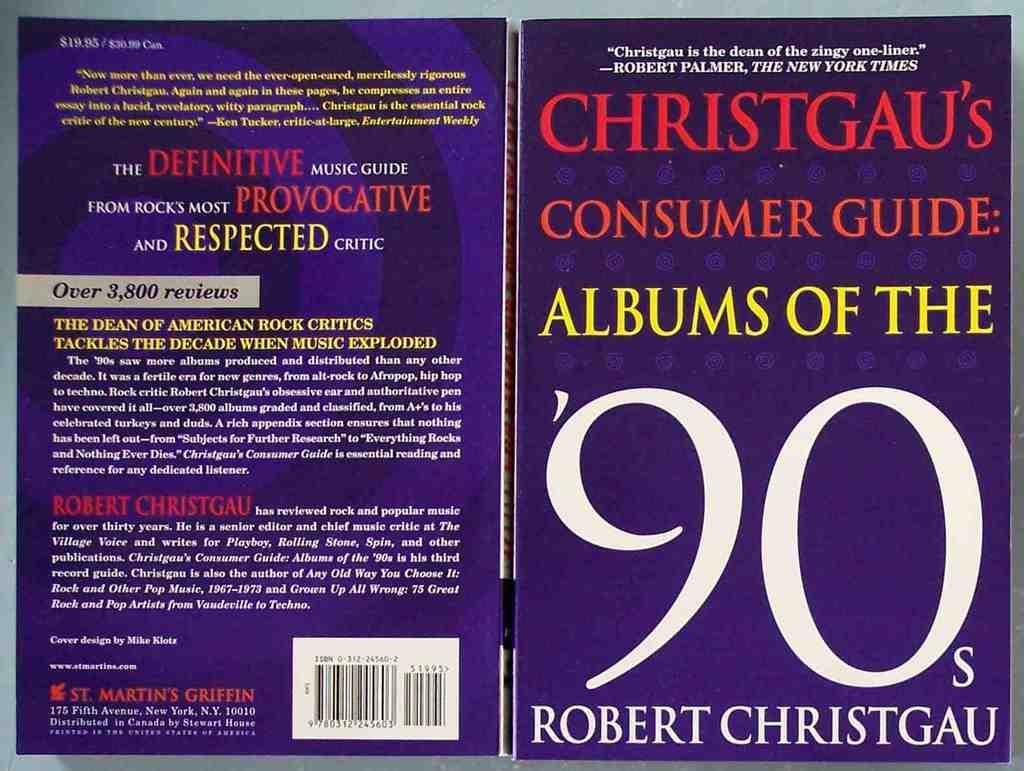Who wrote this book?
Keep it short and to the point. Robert christgau. 